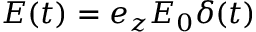Convert formula to latex. <formula><loc_0><loc_0><loc_500><loc_500>\boldsymbol E ( t ) = \boldsymbol e _ { z } E _ { 0 } \delta ( t )</formula> 